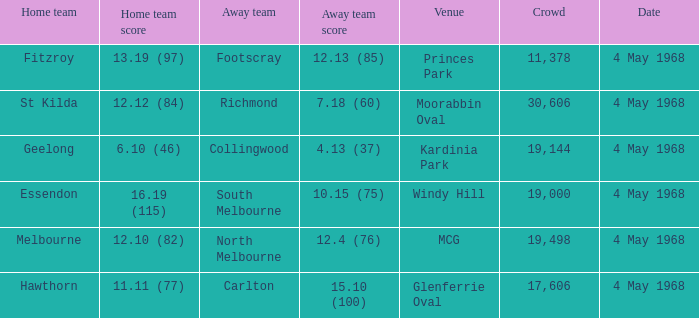How big was the crowd of the team that scored 4.13 (37)? 19144.0. 